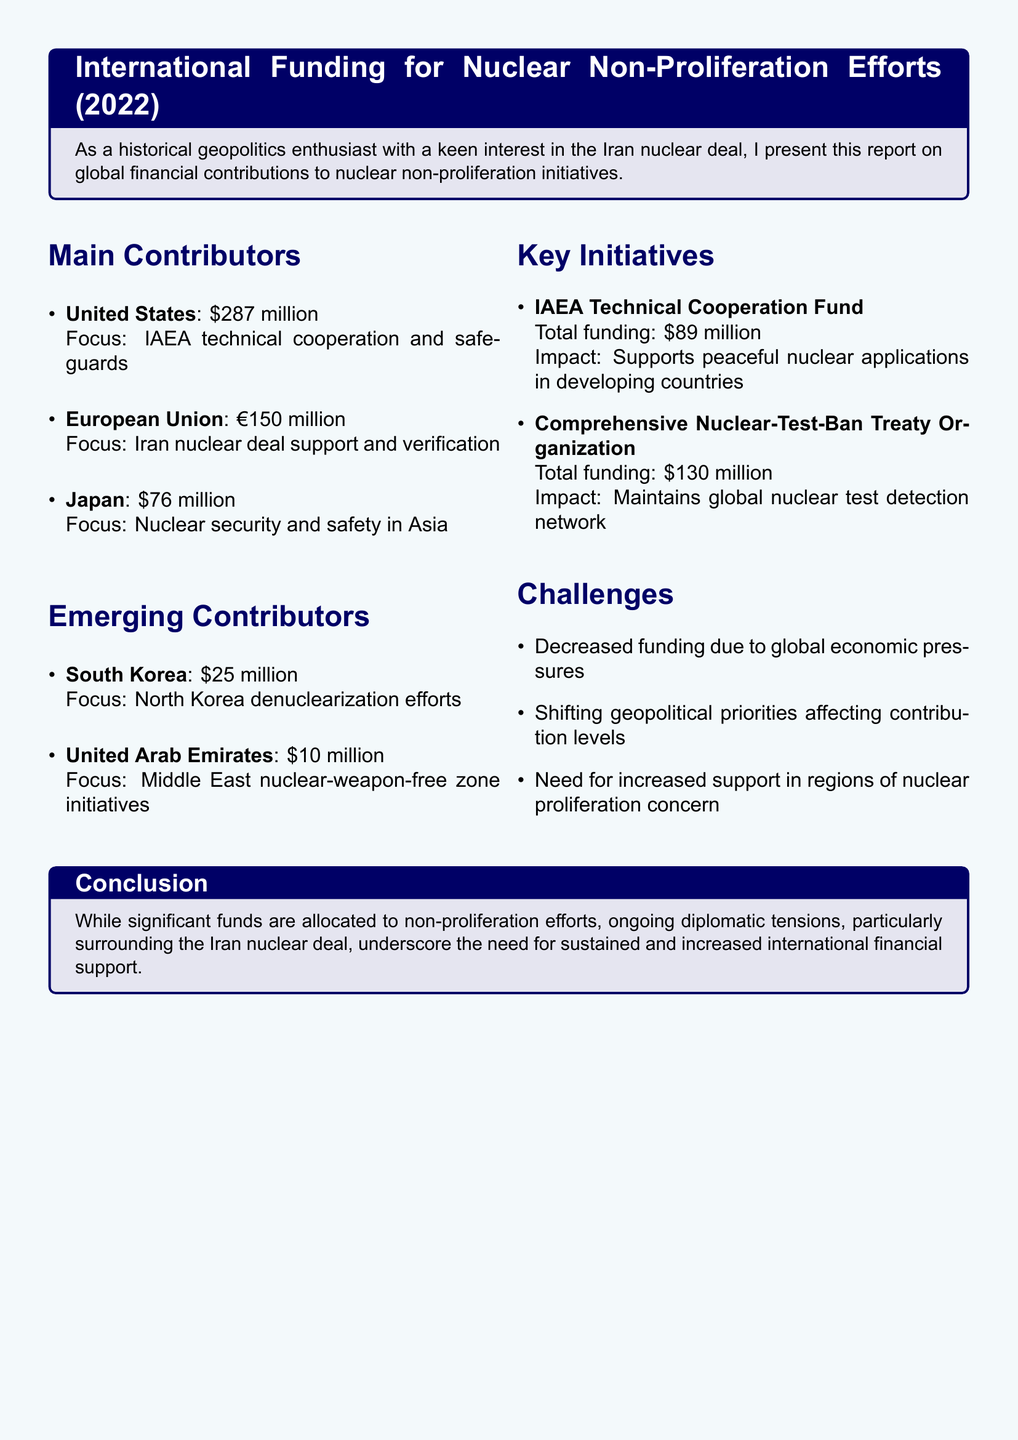What is the total contribution from the United States? The document states that the United States contributed $287 million to nuclear non-proliferation efforts.
Answer: $287 million What is the primary focus of the European Union's contribution? The European Union's primary focus is on supporting and verifying the Iran nuclear deal.
Answer: Iran nuclear deal support and verification How much funding did Japan provide? According to the document, Japan contributed $76 million.
Answer: $76 million What initiative received $130 million in funding? The Comprehensive Nuclear-Test-Ban Treaty Organization is mentioned as receiving $130 million.
Answer: Comprehensive Nuclear-Test-Ban Treaty Organization What is a challenge mentioned in the report? Decreased funding due to global economic pressures is listed as one of the challenges.
Answer: Decreased funding due to global economic pressures Name an emerging contributor to nuclear non-proliferation efforts. South Korea is identified as an emerging contributor in the document.
Answer: South Korea What is the impact of the IAEA Technical Cooperation Fund? The fund supports peaceful nuclear applications in developing countries, as stated in the report.
Answer: Supports peaceful nuclear applications in developing countries What is the total funding amount for the IAEA Technical Cooperation Fund? The document specifies that the total funding for the IAEA Technical Cooperation Fund is $89 million.
Answer: $89 million How much did the United Arab Emirates contribute? The United Arab Emirates contributed $10 million to non-proliferation initiatives.
Answer: $10 million 